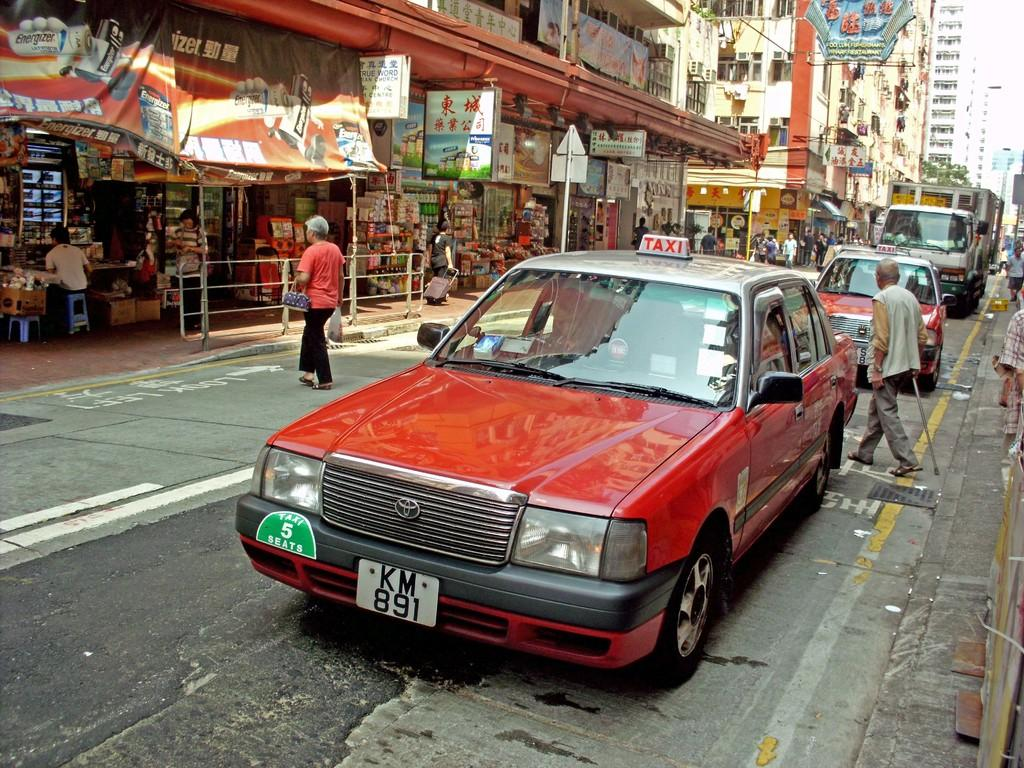<image>
Give a short and clear explanation of the subsequent image. A red taxi with the license plat KM891 